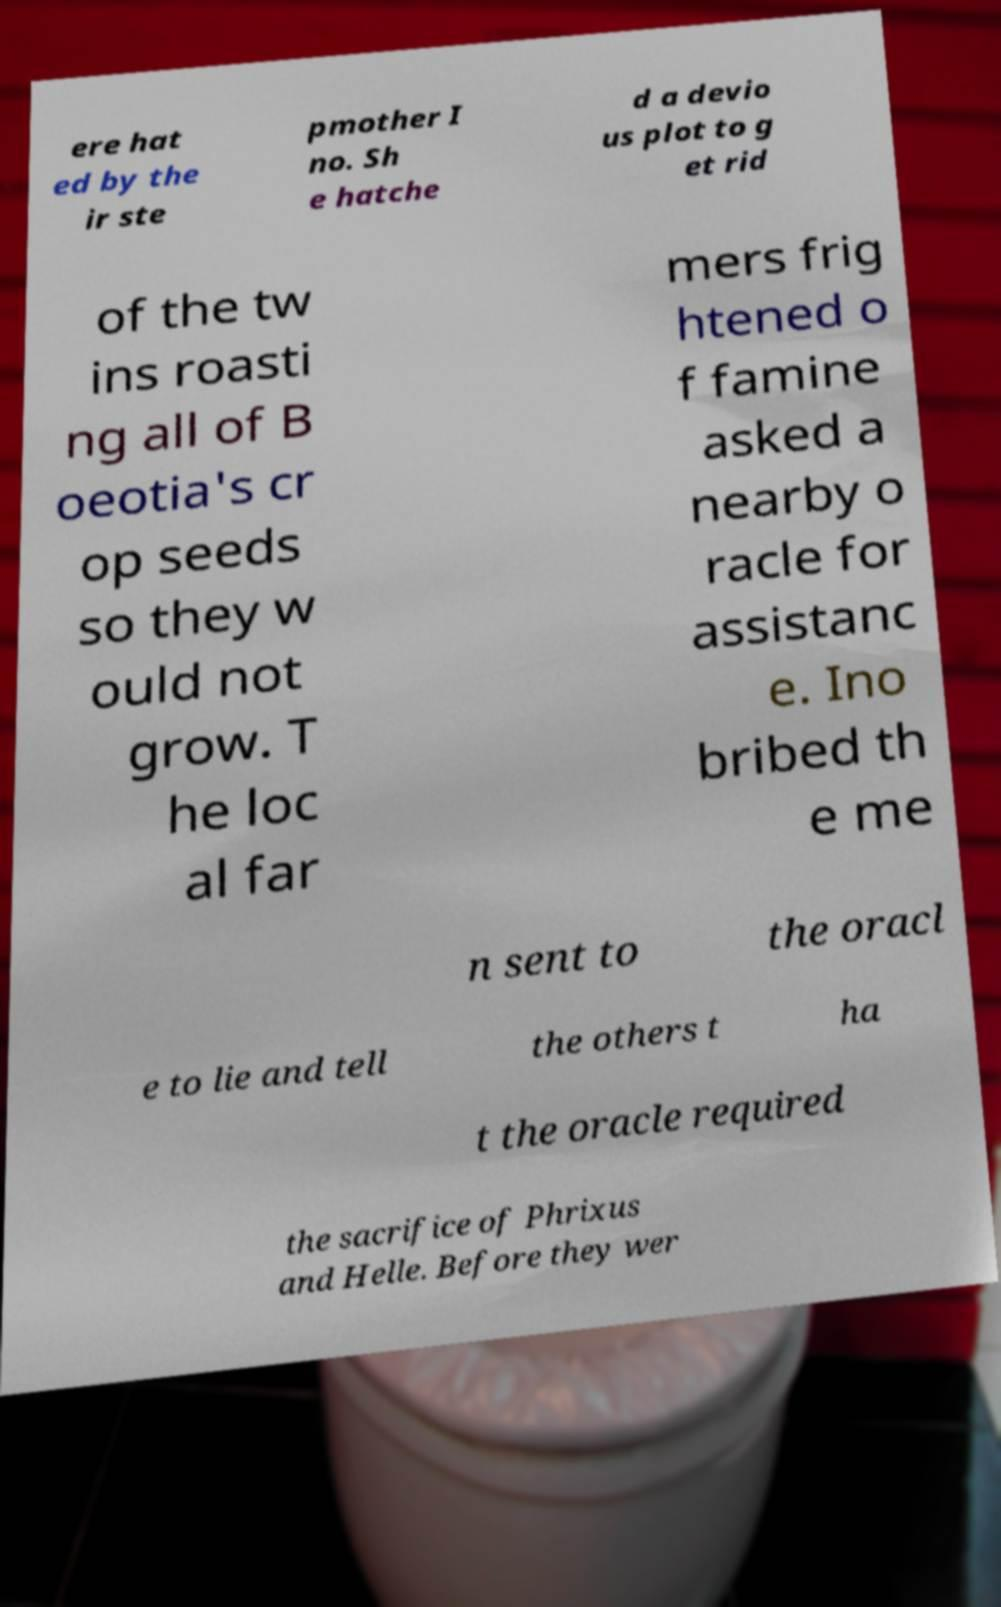There's text embedded in this image that I need extracted. Can you transcribe it verbatim? ere hat ed by the ir ste pmother I no. Sh e hatche d a devio us plot to g et rid of the tw ins roasti ng all of B oeotia's cr op seeds so they w ould not grow. T he loc al far mers frig htened o f famine asked a nearby o racle for assistanc e. Ino bribed th e me n sent to the oracl e to lie and tell the others t ha t the oracle required the sacrifice of Phrixus and Helle. Before they wer 